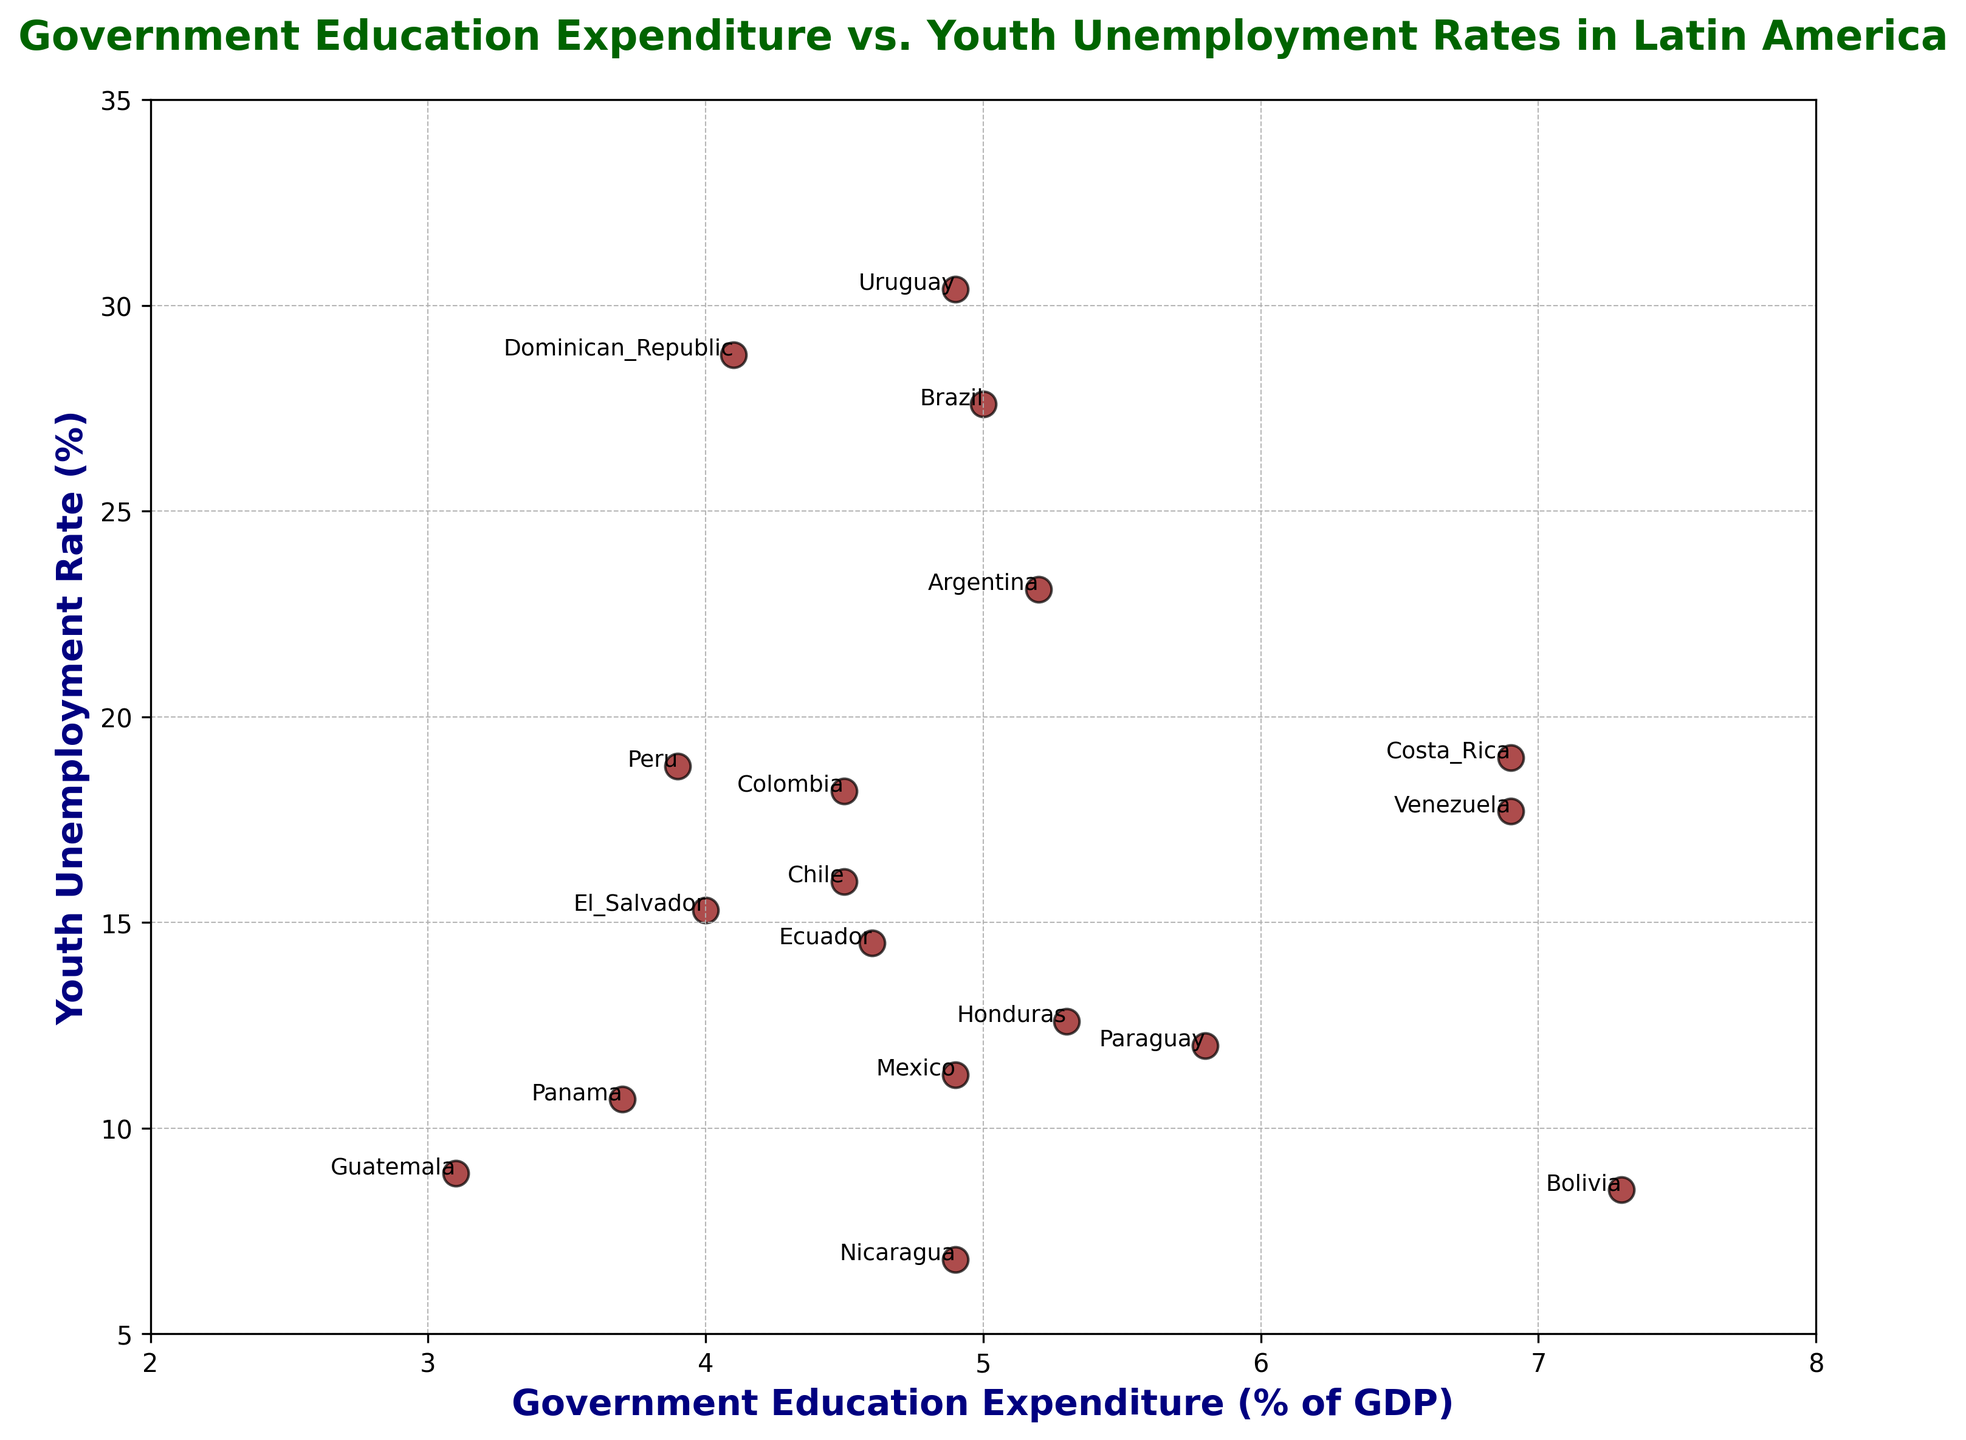Which country has the highest youth unemployment rate? By looking for the data point with the highest position on the y-axis, we can determine the country. Uruguay is at the highest point with a youth unemployment rate of 30.4%.
Answer: Uruguay Which two countries have the closest spending on education as a percentage of GDP? By scanning the x-axis, we see that Argentina and Honduras both have expenditures very close to 5.2%.
Answer: Argentina and Honduras Does a higher government education expenditure correlate with lower or higher youth unemployment rates based on this plot? Observing the spread of data points, countries with both high youth unemployment and high education expenditure like Brazil and Uruguay suggest no clear negative correlation.
Answer: No clear correlation What is the range of government education expenditure among the countries? The minimum expenditure is Guatemala at 3.1% and the maximum is Bolivia at 7.3%. So the range is calculated as 7.3% - 3.1%.
Answer: 4.2% Which country has the lowest youth unemployment rate and what is the corresponding government expenditure on education? By finding the lowest data point on the y-axis, Nicaragua has the lowest youth unemployment rate at 6.8%, and the corresponding education spending is 4.9%.
Answer: Nicaragua; 4.9% Is there any country with both high education expenditure (above 6%) and relatively low youth unemployment (below 10%)? By checking the data points in the specified ranges, Bolivia (7.3% expenditure, 8.5% unemployment) fits the criteria.
Answer: Bolivia Compare the youth unemployment rates between Brazil and Argentina. Which country has a higher rate? Finding both points and comparing their positions on the y-axis shows that Brazil's rate of 27.6% is higher than Argentina's 23.1%.
Answer: Brazil Which country has the closest youth unemployment rate to the average rate of all countries in the dataset? First, calculate the average youth unemployment rate [(23.1+8.5+27.6+16.0+18.2+19.0+28.8+14.5+15.3+8.9+12.6+11.3+6.8+10.7+12.0+18.8+30.4+17.7)/18 = 16.68%]. Then, Venezuela at 17.7% is the closest.
Answer: Venezuela How does Costa Rica compare to Peru in terms of both education expenditure and youth unemployment rate? Costa Rica has a higher government education expenditure (6.9%) compared to Peru (3.9%) and a lower youth unemployment rate (19.0%) compared to Peru (18.8%). So, Costa Rica spends more on education but has a slightly higher unemployment rate.
Answer: Costa Rica spends more, slightly higher unemployment What is the sum of government education expenditures (% of GDP) for the three countries with the lowest youth unemployment rates? The three countries with the lowest youth unemployment rates are Nicaragua (6.8%), Bolivia (8.5%), and Guatemala (8.9%). Their respective education expenditures are 4.9%, 7.3%, and 3.1%. Summing these values: 4.9 + 7.3 + 3.1.
Answer: 15.3% 